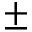<formula> <loc_0><loc_0><loc_500><loc_500>\pm</formula> 